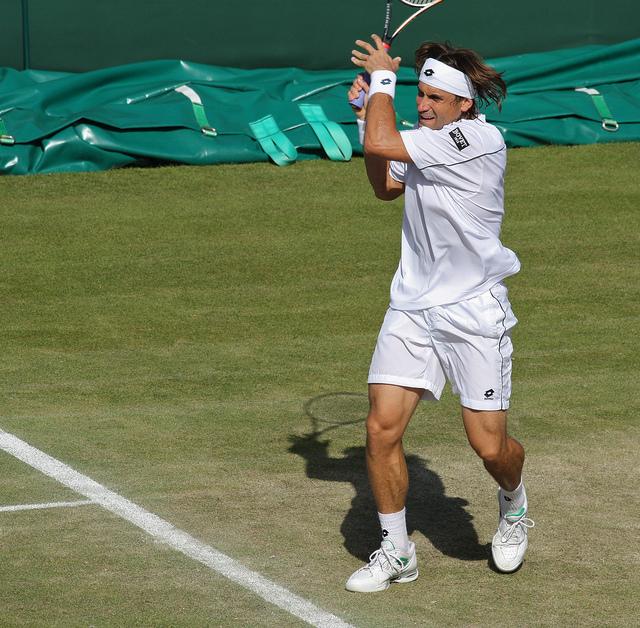What is on the man's head?
Be succinct. Headband. What is the player doing?
Concise answer only. Tennis. What color is the man's shoes?
Write a very short answer. White. 